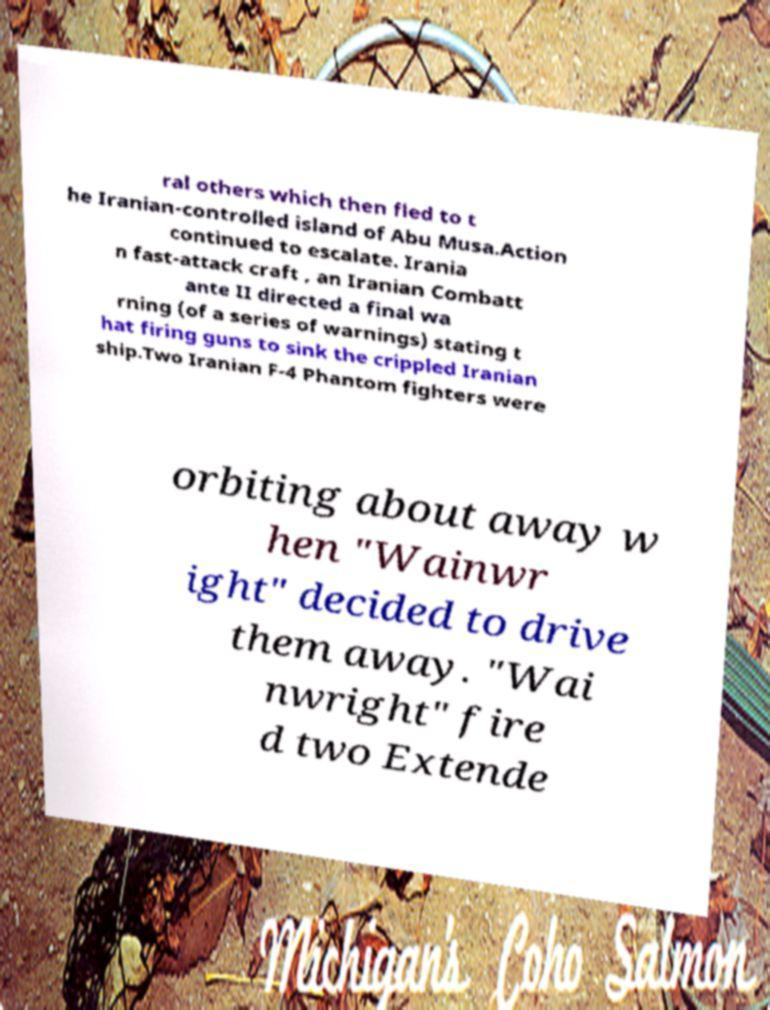Can you read and provide the text displayed in the image?This photo seems to have some interesting text. Can you extract and type it out for me? ral others which then fled to t he Iranian-controlled island of Abu Musa.Action continued to escalate. Irania n fast-attack craft , an Iranian Combatt ante II directed a final wa rning (of a series of warnings) stating t hat firing guns to sink the crippled Iranian ship.Two Iranian F-4 Phantom fighters were orbiting about away w hen "Wainwr ight" decided to drive them away. "Wai nwright" fire d two Extende 